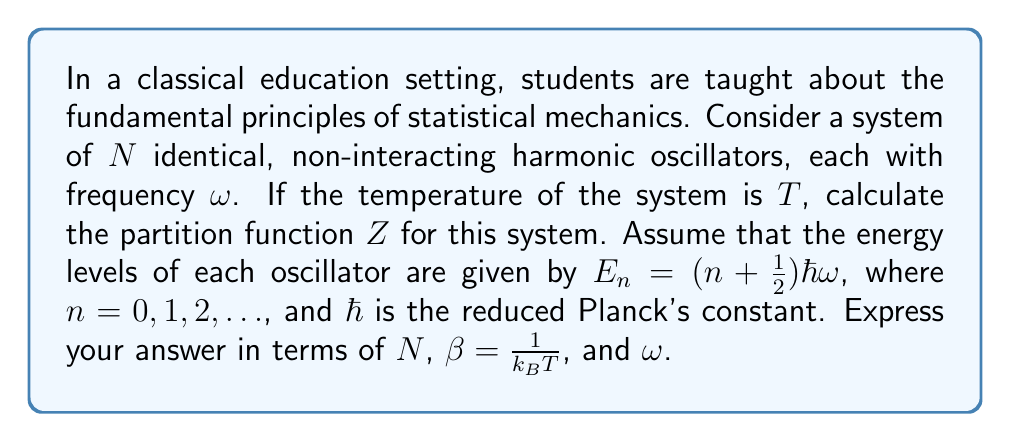Can you solve this math problem? Let's approach this step-by-step:

1) For a single harmonic oscillator, the partition function $z$ is given by:

   $$z = \sum_{n=0}^{\infty} e^{-\beta E_n}$$

2) Substituting the energy levels:

   $$z = \sum_{n=0}^{\infty} e^{-\beta (n + \frac{1}{2})\hbar\omega}$$

3) This can be rewritten as:

   $$z = e^{-\beta \frac{1}{2}\hbar\omega} \sum_{n=0}^{\infty} (e^{-\beta \hbar\omega})^n$$

4) Recognize that this is a geometric series with first term $a=1$ and common ratio $r=e^{-\beta \hbar\omega}$. The sum of an infinite geometric series is given by $\frac{a}{1-r}$ when $|r| < 1$.

5) Therefore:

   $$z = e^{-\beta \frac{1}{2}\hbar\omega} \frac{1}{1 - e^{-\beta \hbar\omega}}$$

6) For a system of $N$ non-interacting oscillators, the total partition function $Z$ is the product of the individual partition functions:

   $$Z = z^N = \left(e^{-\beta \frac{1}{2}\hbar\omega} \frac{1}{1 - e^{-\beta \hbar\omega}}\right)^N$$

7) This can be simplified to:

   $$Z = \frac{e^{-N\beta \frac{1}{2}\hbar\omega}}{(1 - e^{-\beta \hbar\omega})^N}$$

This is the partition function for the system of $N$ non-interacting harmonic oscillators.
Answer: $$Z = \frac{e^{-N\beta \frac{1}{2}\hbar\omega}}{(1 - e^{-\beta \hbar\omega})^N}$$ 